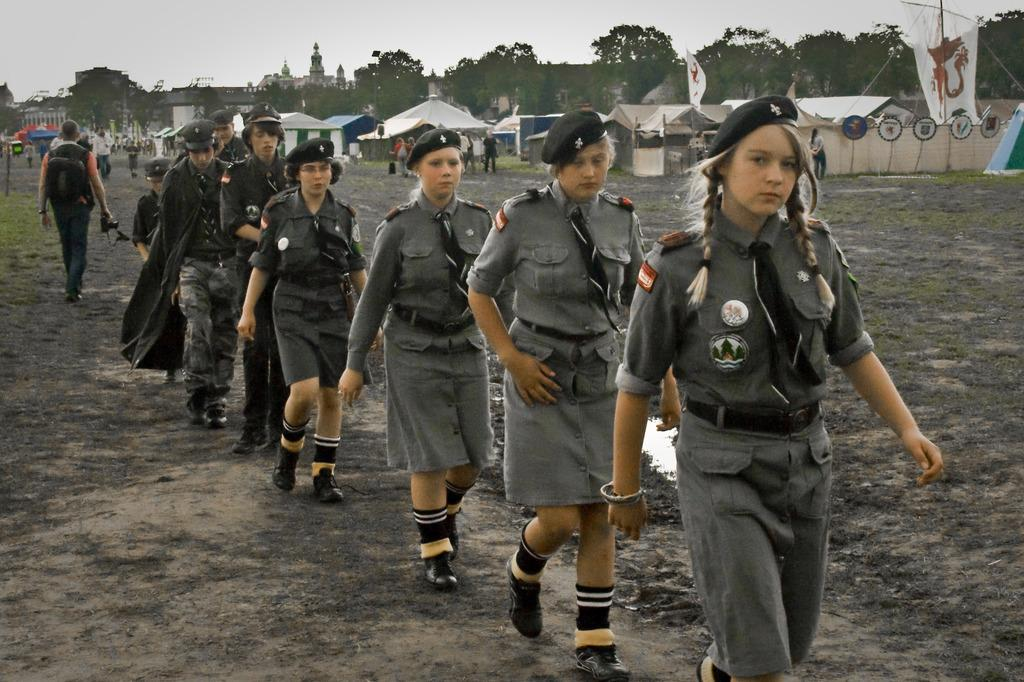What are the people in the image doing? The people in the image are walking. What are the people wearing? The people are wearing uniforms. What structures are present in the image? There are canopies, flags, trees, and buildings in the image. What is visible at the top of the image? The sky is visible at the top of the image. What type of agreement can be seen between the ants in the image? There are no ants present in the image, so it is not possible to determine if there is any agreement between them. 